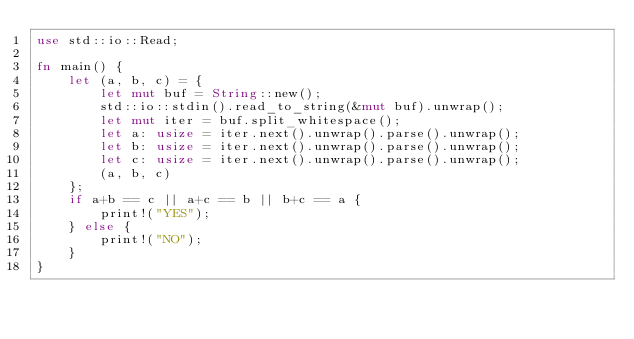<code> <loc_0><loc_0><loc_500><loc_500><_Rust_>use std::io::Read;

fn main() {
    let (a, b, c) = {
        let mut buf = String::new();
        std::io::stdin().read_to_string(&mut buf).unwrap();
        let mut iter = buf.split_whitespace();
        let a: usize = iter.next().unwrap().parse().unwrap();
        let b: usize = iter.next().unwrap().parse().unwrap();
        let c: usize = iter.next().unwrap().parse().unwrap();
        (a, b, c)
    };
    if a+b == c || a+c == b || b+c == a {
        print!("YES");
    } else {
        print!("NO");
    }
}
</code> 